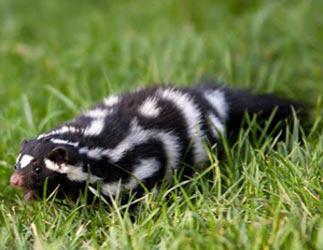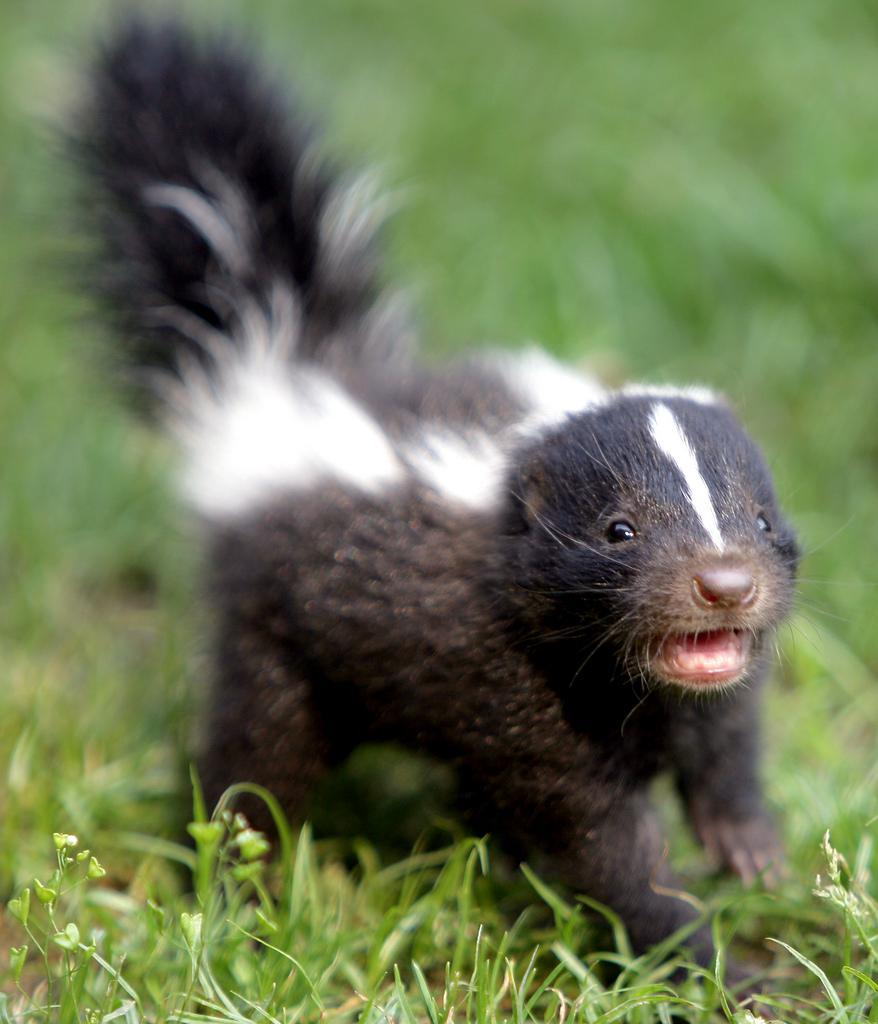The first image is the image on the left, the second image is the image on the right. Assess this claim about the two images: "At least one photo shows two or more skunks facing forward with their tails raised.". Correct or not? Answer yes or no. No. The first image is the image on the left, the second image is the image on the right. For the images shown, is this caption "An image shows a forward-facing row of at least three skunks with white stripes down their faces and tails standing up." true? Answer yes or no. No. 